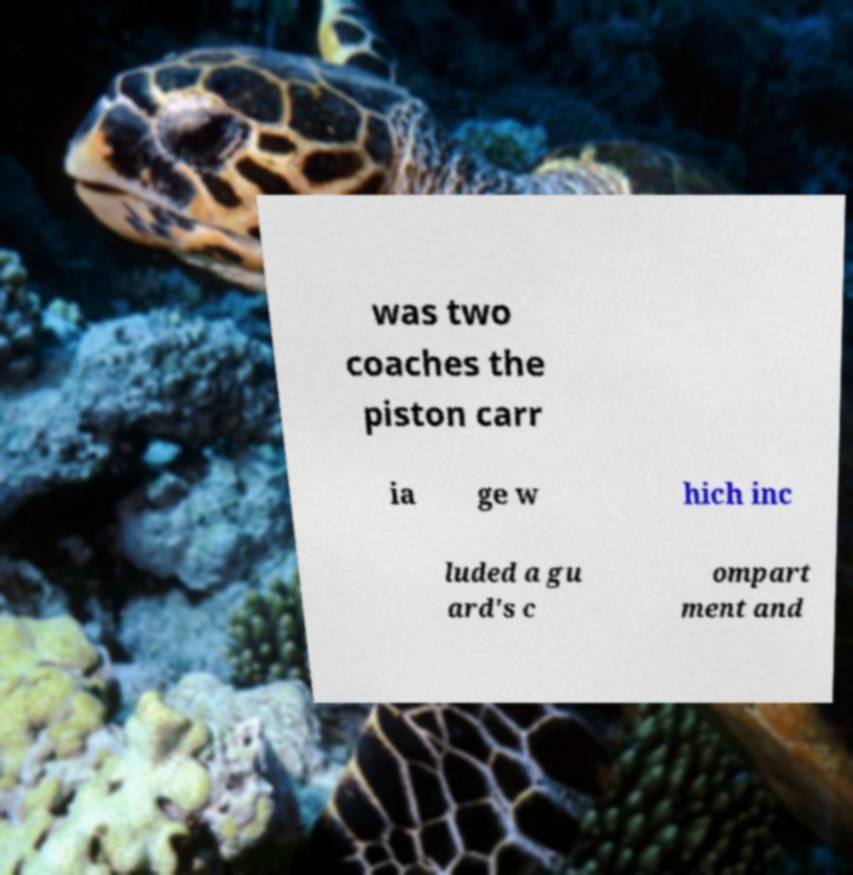Can you accurately transcribe the text from the provided image for me? was two coaches the piston carr ia ge w hich inc luded a gu ard's c ompart ment and 